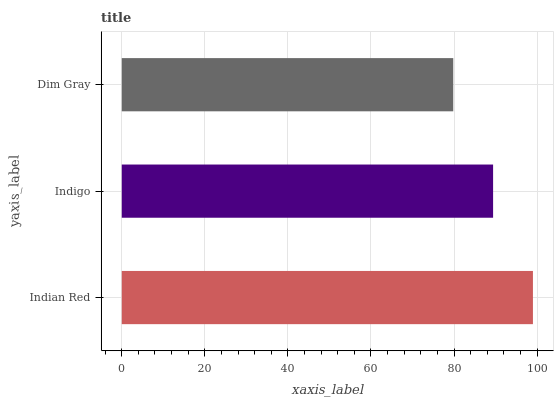Is Dim Gray the minimum?
Answer yes or no. Yes. Is Indian Red the maximum?
Answer yes or no. Yes. Is Indigo the minimum?
Answer yes or no. No. Is Indigo the maximum?
Answer yes or no. No. Is Indian Red greater than Indigo?
Answer yes or no. Yes. Is Indigo less than Indian Red?
Answer yes or no. Yes. Is Indigo greater than Indian Red?
Answer yes or no. No. Is Indian Red less than Indigo?
Answer yes or no. No. Is Indigo the high median?
Answer yes or no. Yes. Is Indigo the low median?
Answer yes or no. Yes. Is Indian Red the high median?
Answer yes or no. No. Is Dim Gray the low median?
Answer yes or no. No. 